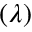Convert formula to latex. <formula><loc_0><loc_0><loc_500><loc_500>( \lambda )</formula> 